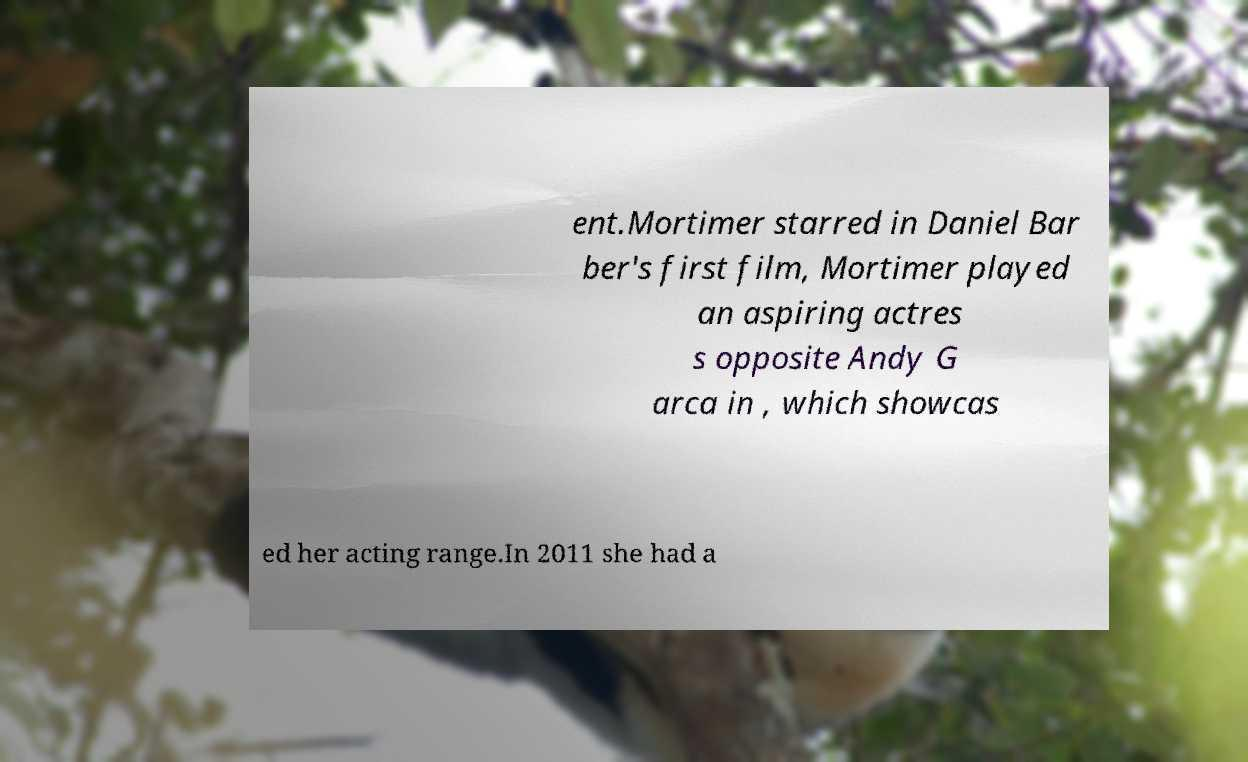Can you accurately transcribe the text from the provided image for me? ent.Mortimer starred in Daniel Bar ber's first film, Mortimer played an aspiring actres s opposite Andy G arca in , which showcas ed her acting range.In 2011 she had a 